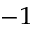<formula> <loc_0><loc_0><loc_500><loc_500>^ { - 1 }</formula> 